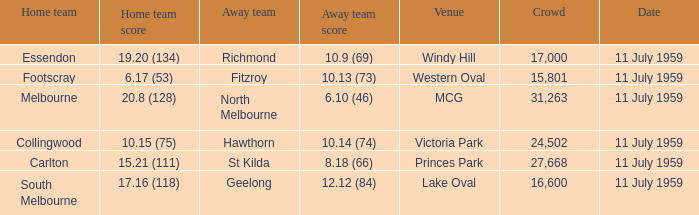How many points does footscray score as the home side? 6.17 (53). 